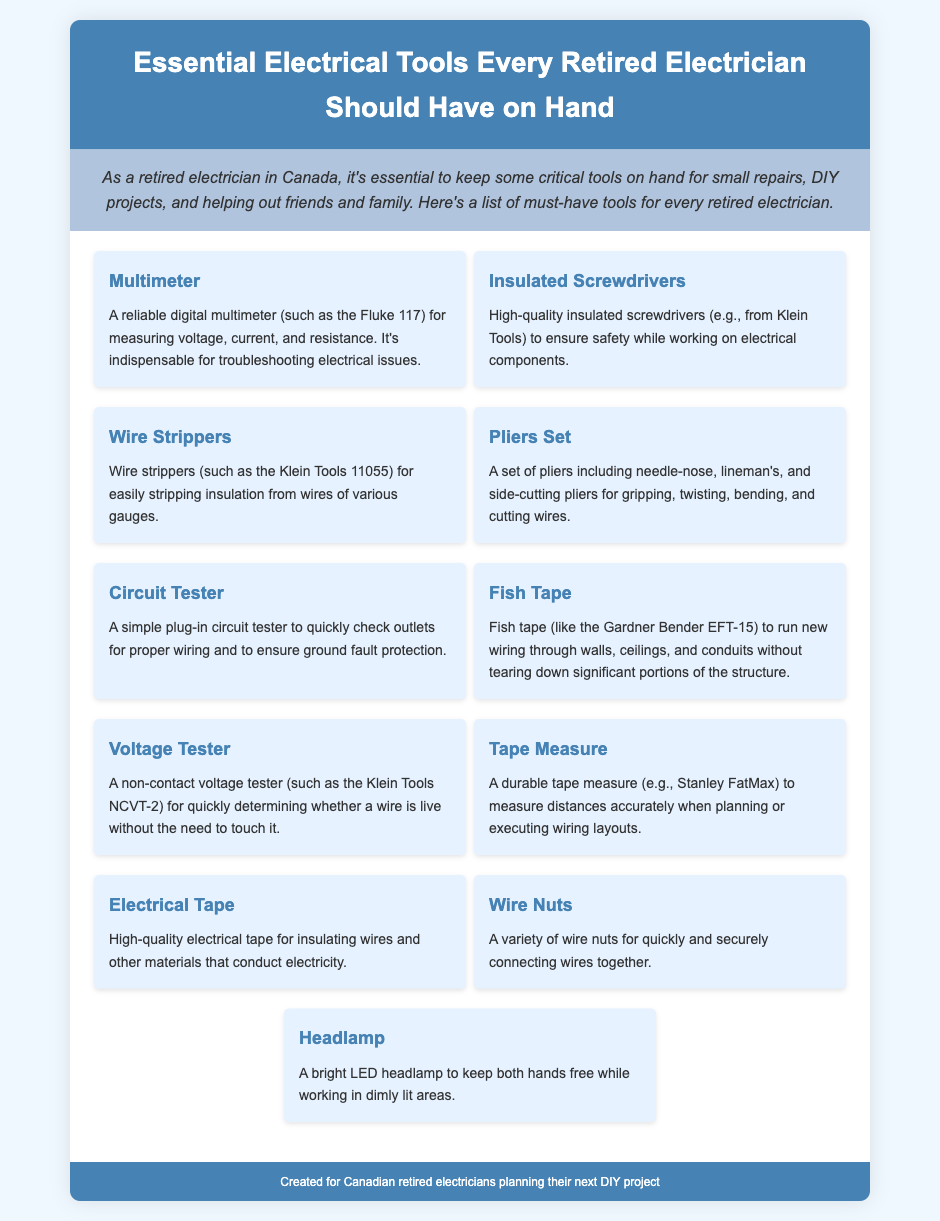What is the first tool listed? The first tool listed in the document is a Multimeter, which is essential for measuring voltage, current, and resistance.
Answer: Multimeter Which brand is mentioned for wire strippers? The document specifies Klein Tools as the brand for wire strippers.
Answer: Klein Tools How many types of pliers are included in the set? The pliers set includes needle-nose, lineman's, and side-cutting pliers, totaling three types.
Answer: Three What purpose does the headlamp serve? The headlamp is used to keep both hands free while working in dimly lit areas.
Answer: Keeping hands free in dimly lit areas What is the function of electrical tape? The electrical tape is used for insulating wires and other materials that conduct electricity.
Answer: Insulating wires Which tool is specifically for checking outlet wiring? The document mentions a Circuit Tester for checking outlets for proper wiring.
Answer: Circuit Tester What kind of voltage tester is recommended? A non-contact voltage tester is recommended for quickly determining whether a wire is live.
Answer: Non-contact voltage tester Which tool is suggested for running new wiring? Fish tape is suggested for running new wiring through walls, ceilings, and conduits.
Answer: Fish tape What is listed as a must-have for small repairs? The document states that essential electrical tools are must-haves for small repairs.
Answer: Essential electrical tools 